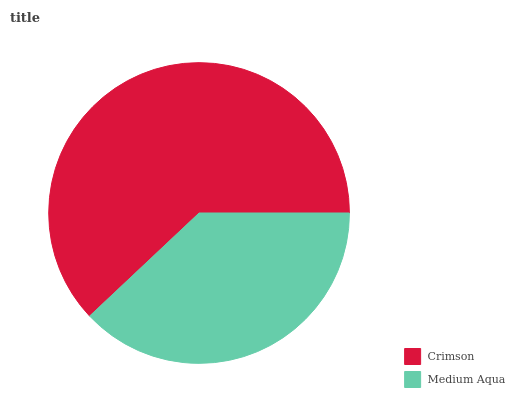Is Medium Aqua the minimum?
Answer yes or no. Yes. Is Crimson the maximum?
Answer yes or no. Yes. Is Medium Aqua the maximum?
Answer yes or no. No. Is Crimson greater than Medium Aqua?
Answer yes or no. Yes. Is Medium Aqua less than Crimson?
Answer yes or no. Yes. Is Medium Aqua greater than Crimson?
Answer yes or no. No. Is Crimson less than Medium Aqua?
Answer yes or no. No. Is Crimson the high median?
Answer yes or no. Yes. Is Medium Aqua the low median?
Answer yes or no. Yes. Is Medium Aqua the high median?
Answer yes or no. No. Is Crimson the low median?
Answer yes or no. No. 